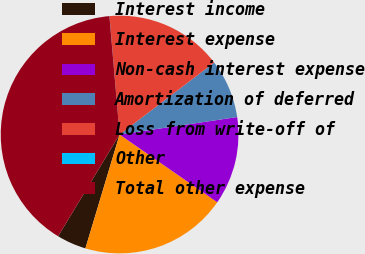<chart> <loc_0><loc_0><loc_500><loc_500><pie_chart><fcel>Interest income<fcel>Interest expense<fcel>Non-cash interest expense<fcel>Amortization of deferred<fcel>Loss from write-off of<fcel>Other<fcel>Total other expense<nl><fcel>4.01%<fcel>19.99%<fcel>12.0%<fcel>8.01%<fcel>16.0%<fcel>0.01%<fcel>39.98%<nl></chart> 